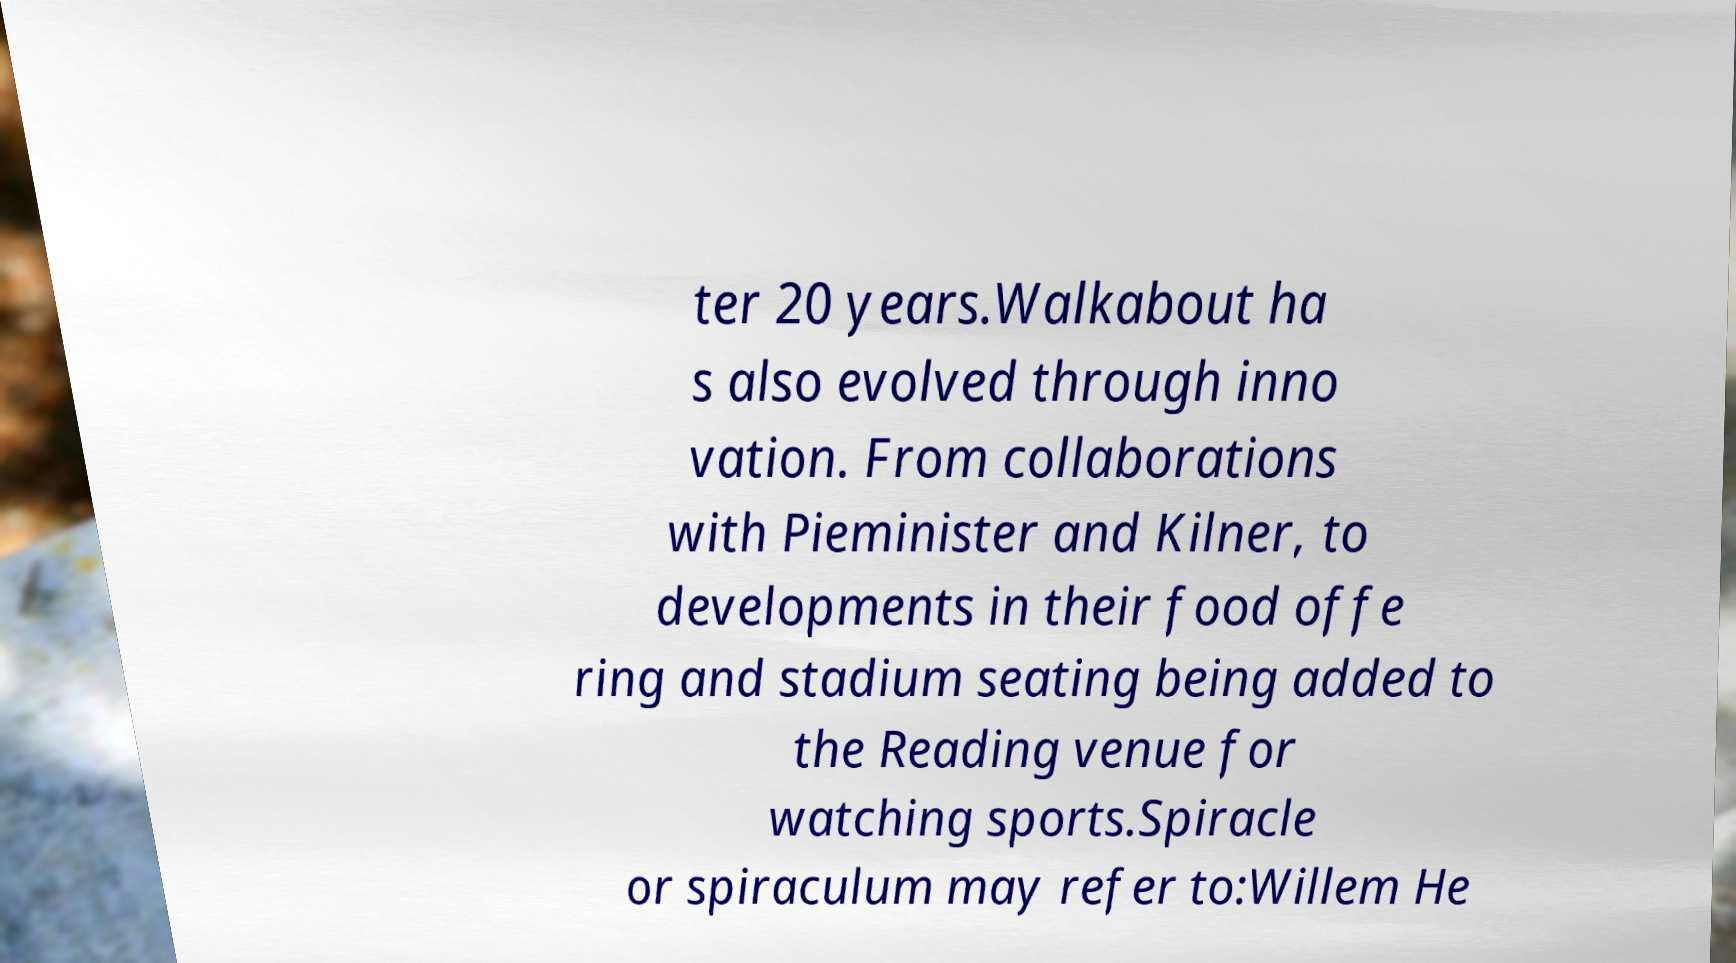For documentation purposes, I need the text within this image transcribed. Could you provide that? ter 20 years.Walkabout ha s also evolved through inno vation. From collaborations with Pieminister and Kilner, to developments in their food offe ring and stadium seating being added to the Reading venue for watching sports.Spiracle or spiraculum may refer to:Willem He 